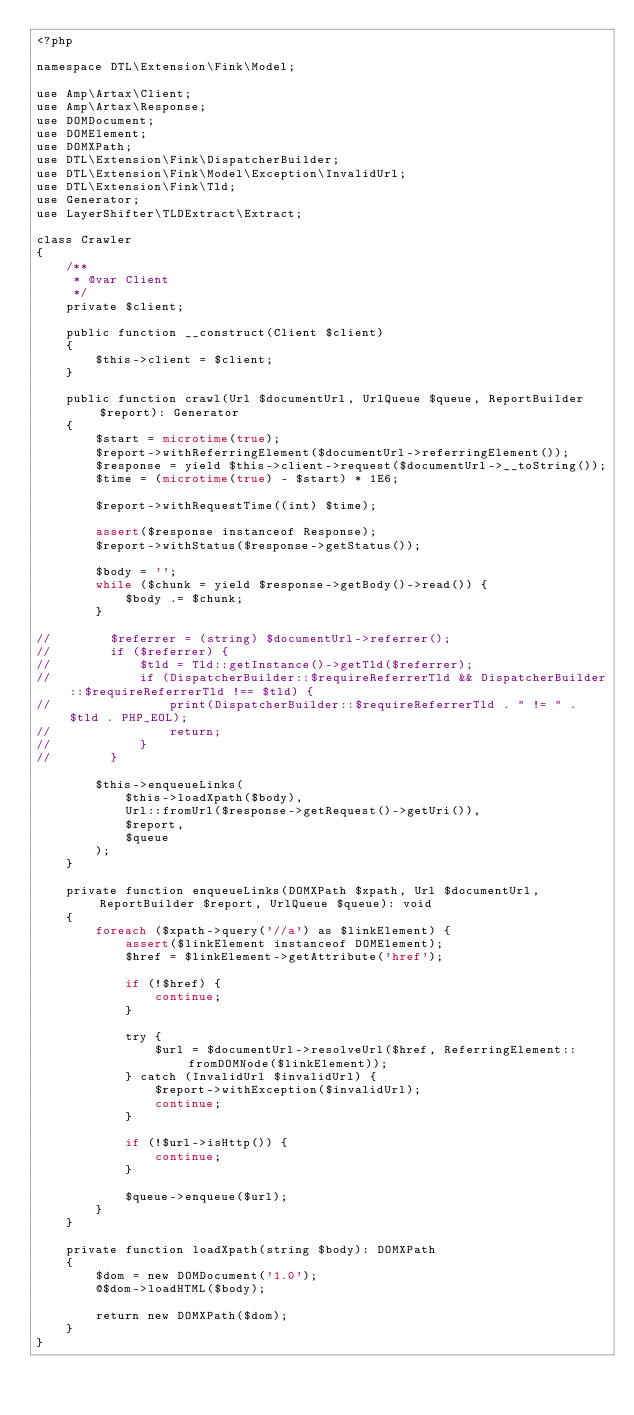Convert code to text. <code><loc_0><loc_0><loc_500><loc_500><_PHP_><?php

namespace DTL\Extension\Fink\Model;

use Amp\Artax\Client;
use Amp\Artax\Response;
use DOMDocument;
use DOMElement;
use DOMXPath;
use DTL\Extension\Fink\DispatcherBuilder;
use DTL\Extension\Fink\Model\Exception\InvalidUrl;
use DTL\Extension\Fink\Tld;
use Generator;
use LayerShifter\TLDExtract\Extract;

class Crawler
{
    /**
     * @var Client
     */
    private $client;

    public function __construct(Client $client)
    {
        $this->client = $client;
    }

    public function crawl(Url $documentUrl, UrlQueue $queue, ReportBuilder $report): Generator
    {
        $start = microtime(true);
        $report->withReferringElement($documentUrl->referringElement());
        $response = yield $this->client->request($documentUrl->__toString());
        $time = (microtime(true) - $start) * 1E6;

        $report->withRequestTime((int) $time);

        assert($response instanceof Response);
        $report->withStatus($response->getStatus());

        $body = '';
        while ($chunk = yield $response->getBody()->read()) {
            $body .= $chunk;
        }

//        $referrer = (string) $documentUrl->referrer();
//        if ($referrer) {
//            $tld = Tld::getInstance()->getTld($referrer);
//            if (DispatcherBuilder::$requireReferrerTld && DispatcherBuilder::$requireReferrerTld !== $tld) {
//                print(DispatcherBuilder::$requireReferrerTld . " != " . $tld . PHP_EOL);
//                return;
//            }
//        }

        $this->enqueueLinks(
            $this->loadXpath($body),
            Url::fromUrl($response->getRequest()->getUri()),
            $report,
            $queue
        );
    }

    private function enqueueLinks(DOMXPath $xpath, Url $documentUrl, ReportBuilder $report, UrlQueue $queue): void
    {
        foreach ($xpath->query('//a') as $linkElement) {
            assert($linkElement instanceof DOMElement);
            $href = $linkElement->getAttribute('href');
        
            if (!$href) {
                continue;
            }
        
            try {
                $url = $documentUrl->resolveUrl($href, ReferringElement::fromDOMNode($linkElement));
            } catch (InvalidUrl $invalidUrl) {
                $report->withException($invalidUrl);
                continue;
            }
        
            if (!$url->isHttp()) {
                continue;
            }

            $queue->enqueue($url);
        }
    }

    private function loadXpath(string $body): DOMXPath
    {
        $dom = new DOMDocument('1.0');
        @$dom->loadHTML($body);

        return new DOMXPath($dom);
    }
}
</code> 